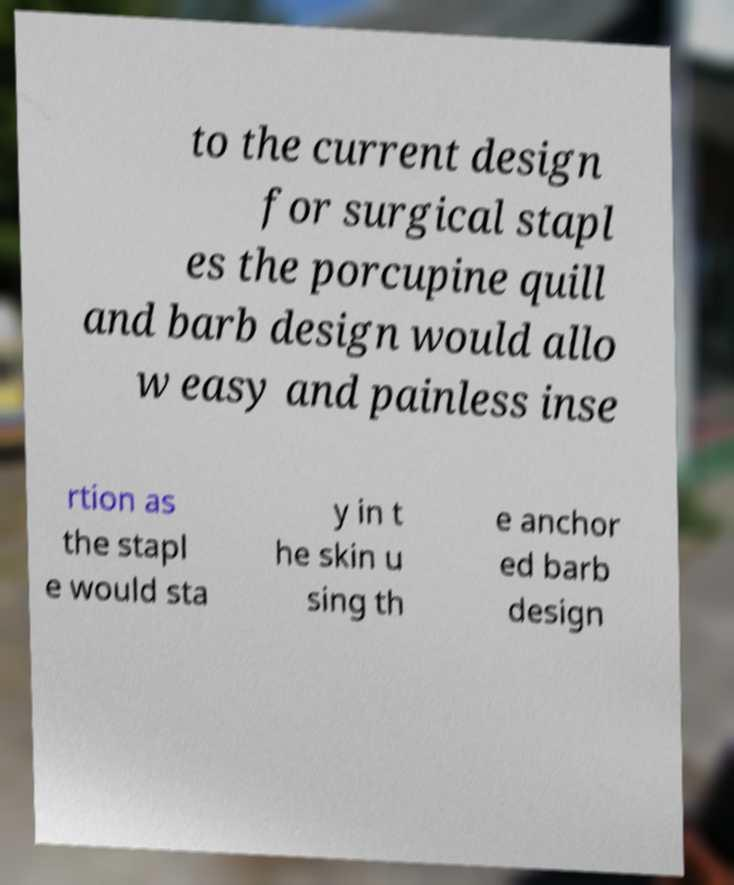Please identify and transcribe the text found in this image. to the current design for surgical stapl es the porcupine quill and barb design would allo w easy and painless inse rtion as the stapl e would sta y in t he skin u sing th e anchor ed barb design 